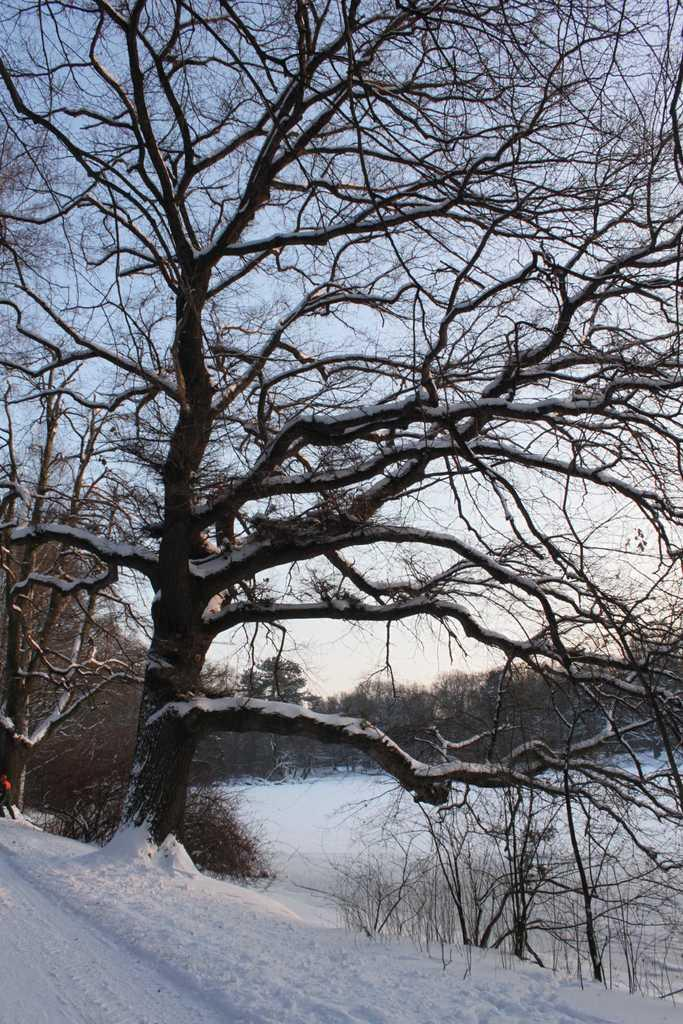What type of vegetation is visible in the image? There are trees in the image. What is present at the bottom of the image? There is snow at the bottom of the image. What part of the natural environment is visible in the image? The sky is visible in the background of the image. What type of office can be seen in the background of the image? There is no office present in the image; it features trees, snow, and the sky. How does the wave interact with the trees in the image? There is no wave present in the image; it features trees, snow, and the sky. 